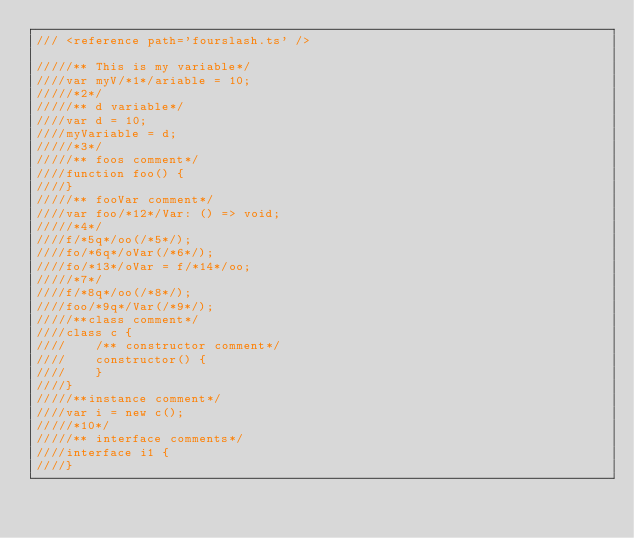<code> <loc_0><loc_0><loc_500><loc_500><_TypeScript_>/// <reference path='fourslash.ts' />

/////** This is my variable*/
////var myV/*1*/ariable = 10;
/////*2*/
/////** d variable*/
////var d = 10;
////myVariable = d;
/////*3*/
/////** foos comment*/
////function foo() {
////}
/////** fooVar comment*/
////var foo/*12*/Var: () => void;
/////*4*/
////f/*5q*/oo(/*5*/);
////fo/*6q*/oVar(/*6*/);
////fo/*13*/oVar = f/*14*/oo;
/////*7*/
////f/*8q*/oo(/*8*/);
////foo/*9q*/Var(/*9*/);
/////**class comment*/
////class c {
////    /** constructor comment*/
////    constructor() {
////    }
////}
/////**instance comment*/
////var i = new c();
/////*10*/
/////** interface comments*/
////interface i1 {
////}</code> 